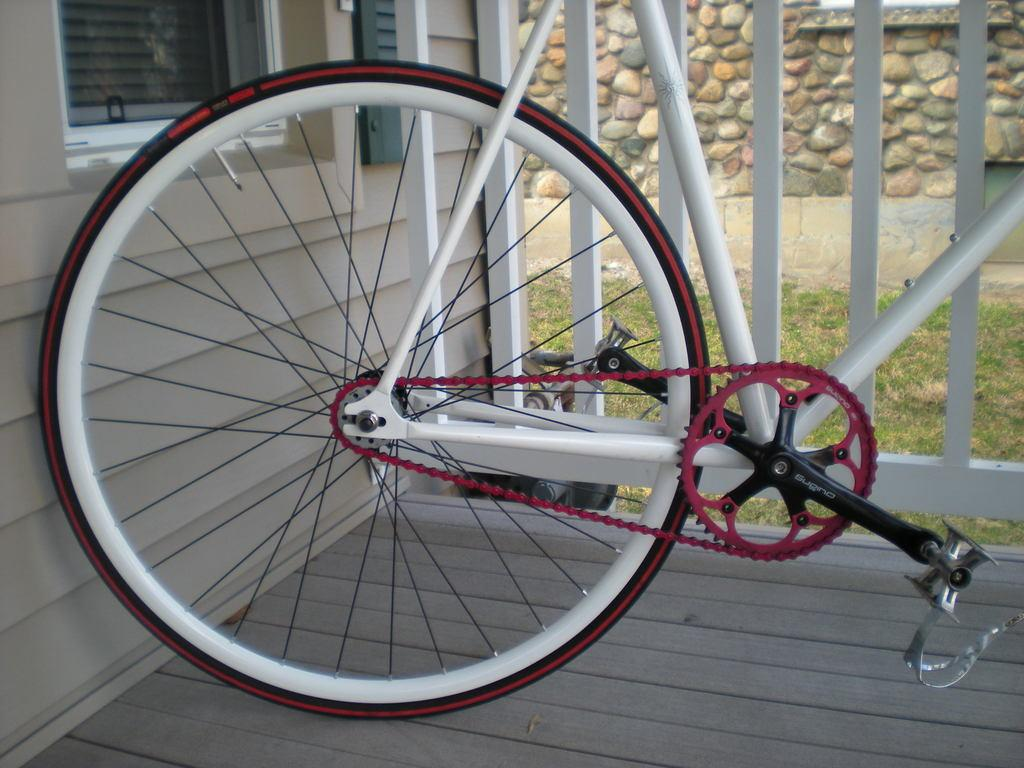What is the main object in the image? There is a bicycle in the image. On what surface is the bicycle placed? The bicycle is on a wooden surface. What can be seen in the background of the image? There is a house, a wooden fence, grass, and a wall in the background of the image. What color is the crayon used to draw the bicycle in the image? There is no crayon or drawing present in the image; it is a photograph of an actual bicycle. What is the value of the bicycle in the image? The value of the bicycle cannot be determined from the image alone, as it does not provide information about the bicycle's make, model, or condition. 